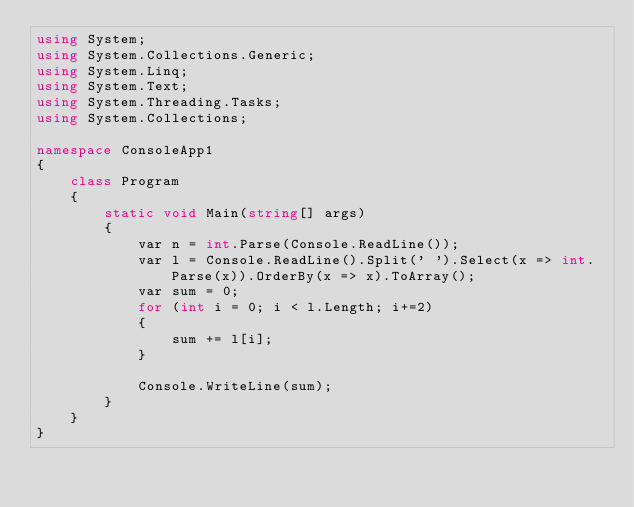Convert code to text. <code><loc_0><loc_0><loc_500><loc_500><_C#_>using System;
using System.Collections.Generic;
using System.Linq;
using System.Text;
using System.Threading.Tasks;
using System.Collections;

namespace ConsoleApp1
{
    class Program
    {
        static void Main(string[] args)
        {
            var n = int.Parse(Console.ReadLine());
            var l = Console.ReadLine().Split(' ').Select(x => int.Parse(x)).OrderBy(x => x).ToArray();
            var sum = 0;
            for (int i = 0; i < l.Length; i+=2)
            {
                sum += l[i];
            }

            Console.WriteLine(sum);
        }
    }
}
</code> 